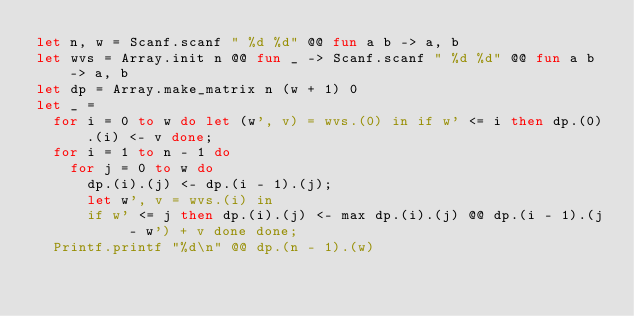<code> <loc_0><loc_0><loc_500><loc_500><_OCaml_>let n, w = Scanf.scanf " %d %d" @@ fun a b -> a, b
let wvs = Array.init n @@ fun _ -> Scanf.scanf " %d %d" @@ fun a b -> a, b
let dp = Array.make_matrix n (w + 1) 0
let _ =
  for i = 0 to w do let (w', v) = wvs.(0) in if w' <= i then dp.(0).(i) <- v done;
  for i = 1 to n - 1 do
    for j = 0 to w do
      dp.(i).(j) <- dp.(i - 1).(j);
      let w', v = wvs.(i) in
      if w' <= j then dp.(i).(j) <- max dp.(i).(j) @@ dp.(i - 1).(j - w') + v done done;
  Printf.printf "%d\n" @@ dp.(n - 1).(w)</code> 